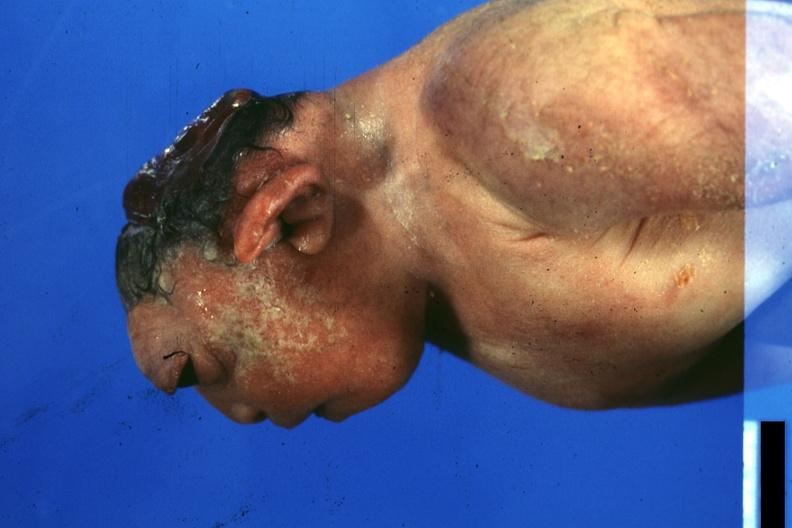s anencephaly present?
Answer the question using a single word or phrase. Yes 